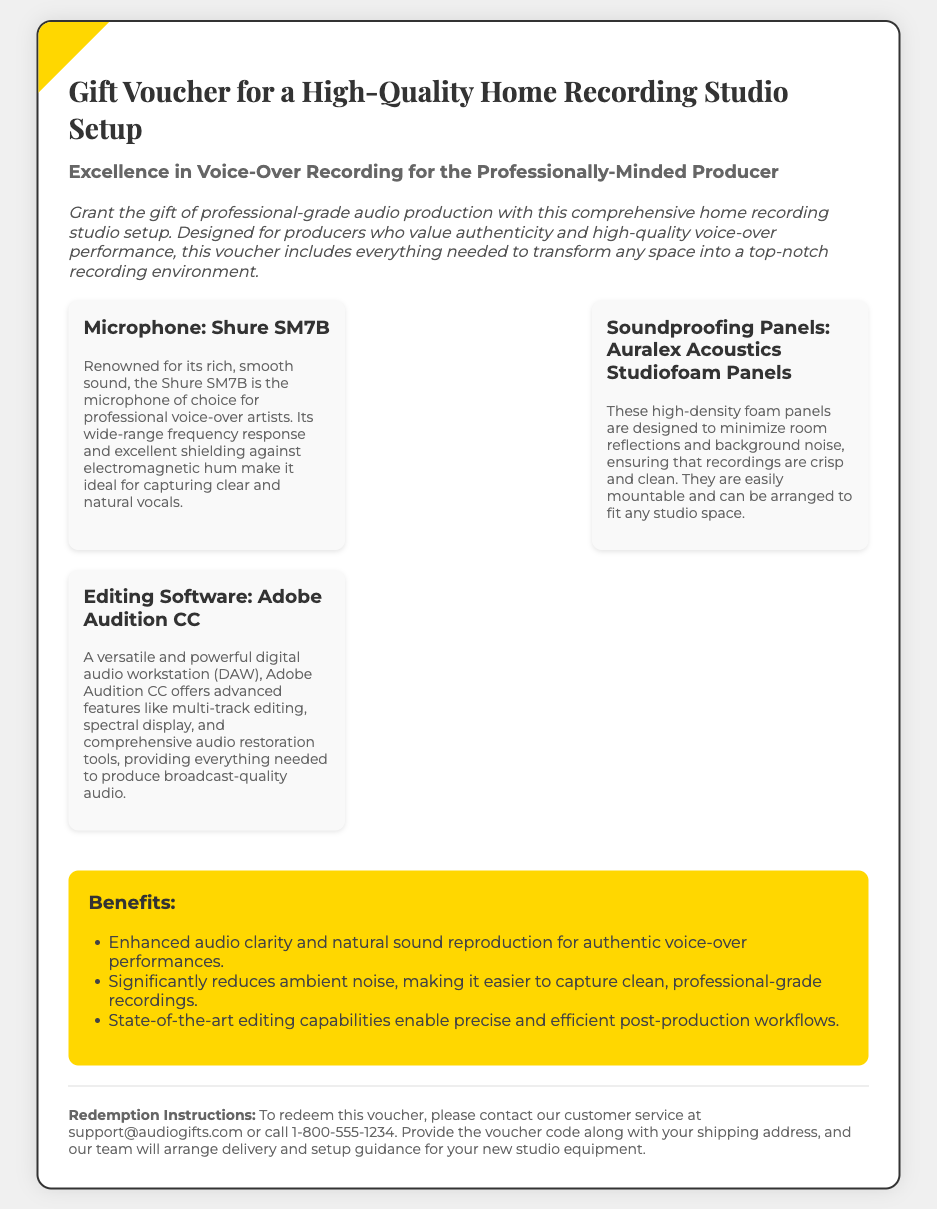what is the title of the voucher? The title is prominently displayed at the top of the document as the main heading.
Answer: Gift Voucher for a High-Quality Home Recording Studio Setup who is the target audience for this gift voucher? The document states that it's designed for a specific group interested in quality production work.
Answer: Professionally-Minded Producer what microphone is included in the setup? The included microphone is mentioned as part of the item descriptions.
Answer: Shure SM7B what is the name of the soundproofing panels? The soundproofing panels are specified with a recognizable product name in the document.
Answer: Auralex Acoustics Studiofoam Panels what is the name of the editing software provided? The editing software is highlighted in a clear manner as one of the setup components.
Answer: Adobe Audition CC how many benefits are listed? The number of benefits can be determined by counting the items in the benefits section.
Answer: Three what should you do to redeem the voucher? The redemption instructions provide specific actions to take for using the voucher.
Answer: Contact customer service what type of audio improvements does this setup promise? The benefits section indicates expected enhancements from using the studio setup.
Answer: Enhanced audio clarity which email should be contacted for support? The document provides a specific email for queries related to redemption.
Answer: support@audiogifts.com 